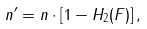<formula> <loc_0><loc_0><loc_500><loc_500>n ^ { \prime } = n \cdot \left [ 1 - H _ { 2 } ( F ) \right ] ,</formula> 